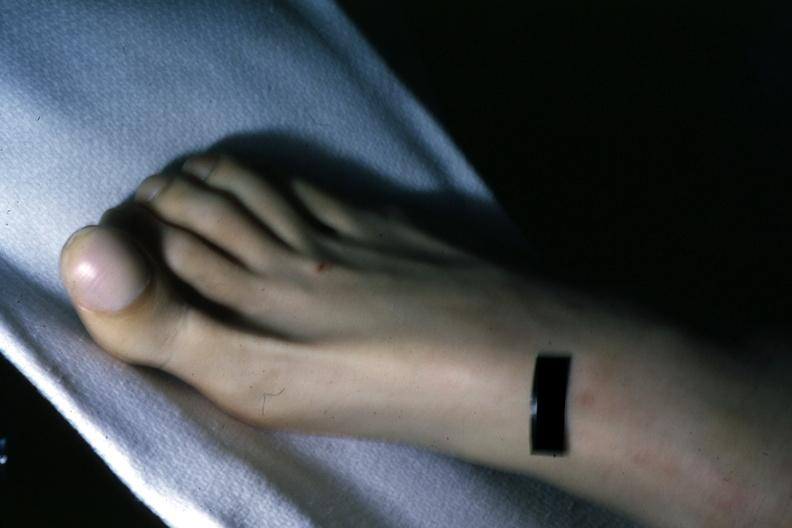what is present?
Answer the question using a single word or phrase. Pulmonary osteoarthropathy 